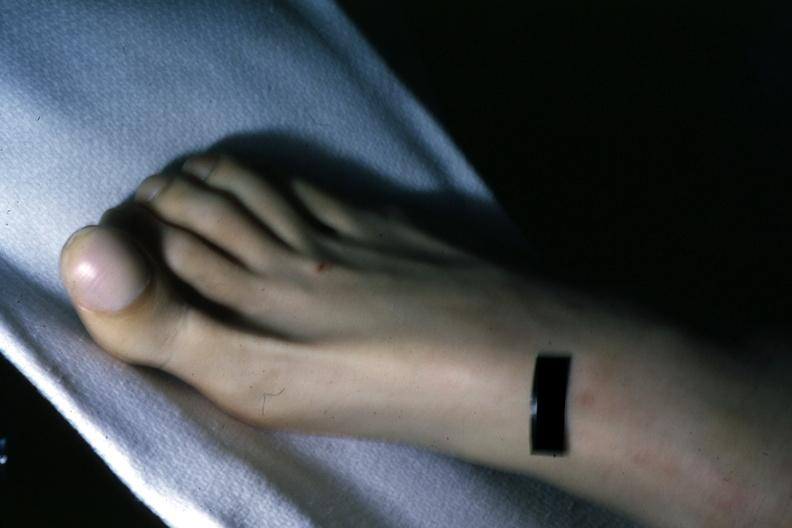what is present?
Answer the question using a single word or phrase. Pulmonary osteoarthropathy 